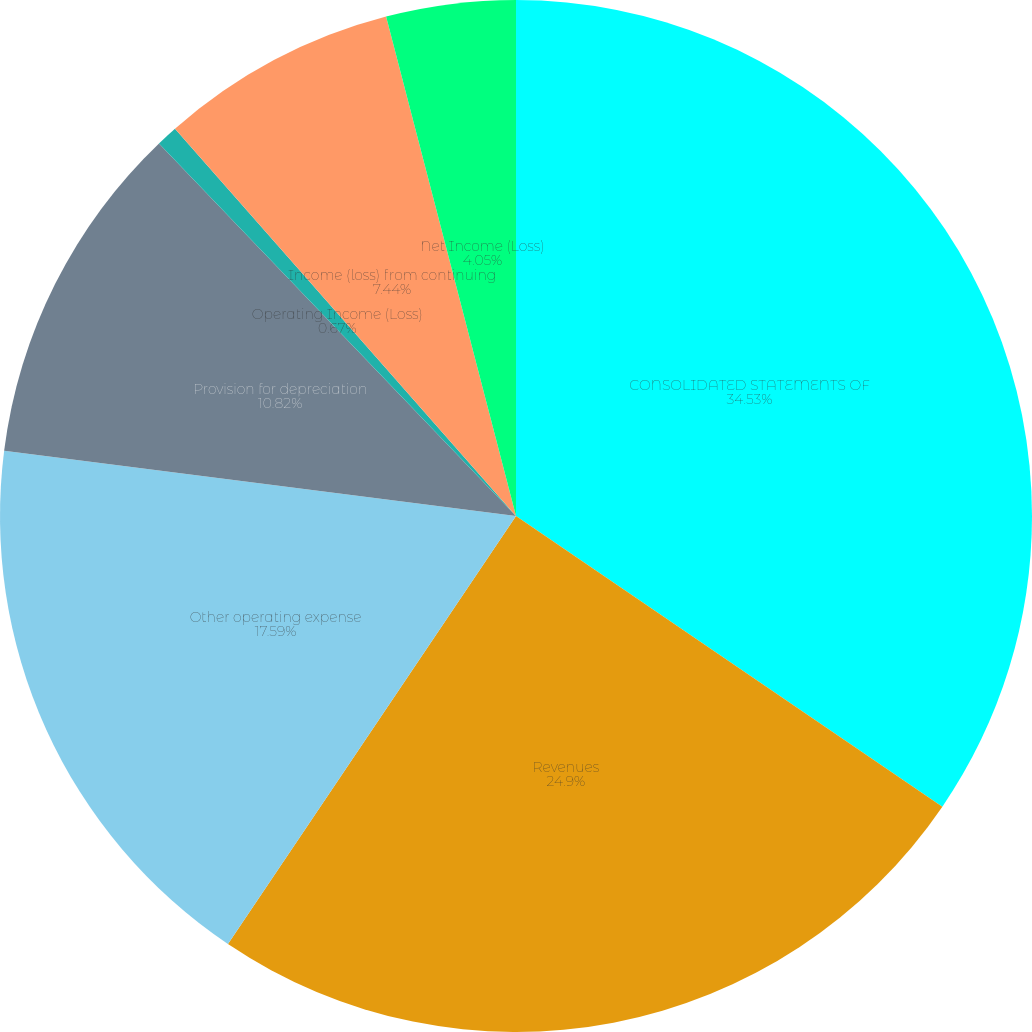Convert chart to OTSL. <chart><loc_0><loc_0><loc_500><loc_500><pie_chart><fcel>CONSOLIDATED STATEMENTS OF<fcel>Revenues<fcel>Other operating expense<fcel>Provision for depreciation<fcel>Operating Income (Loss)<fcel>Income (loss) from continuing<fcel>Net Income (Loss)<nl><fcel>34.52%<fcel>24.9%<fcel>17.59%<fcel>10.82%<fcel>0.67%<fcel>7.44%<fcel>4.05%<nl></chart> 